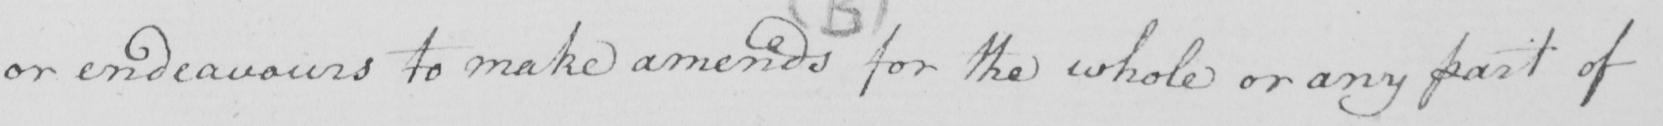What does this handwritten line say? or endeavours to make amends for the whole or any part of 